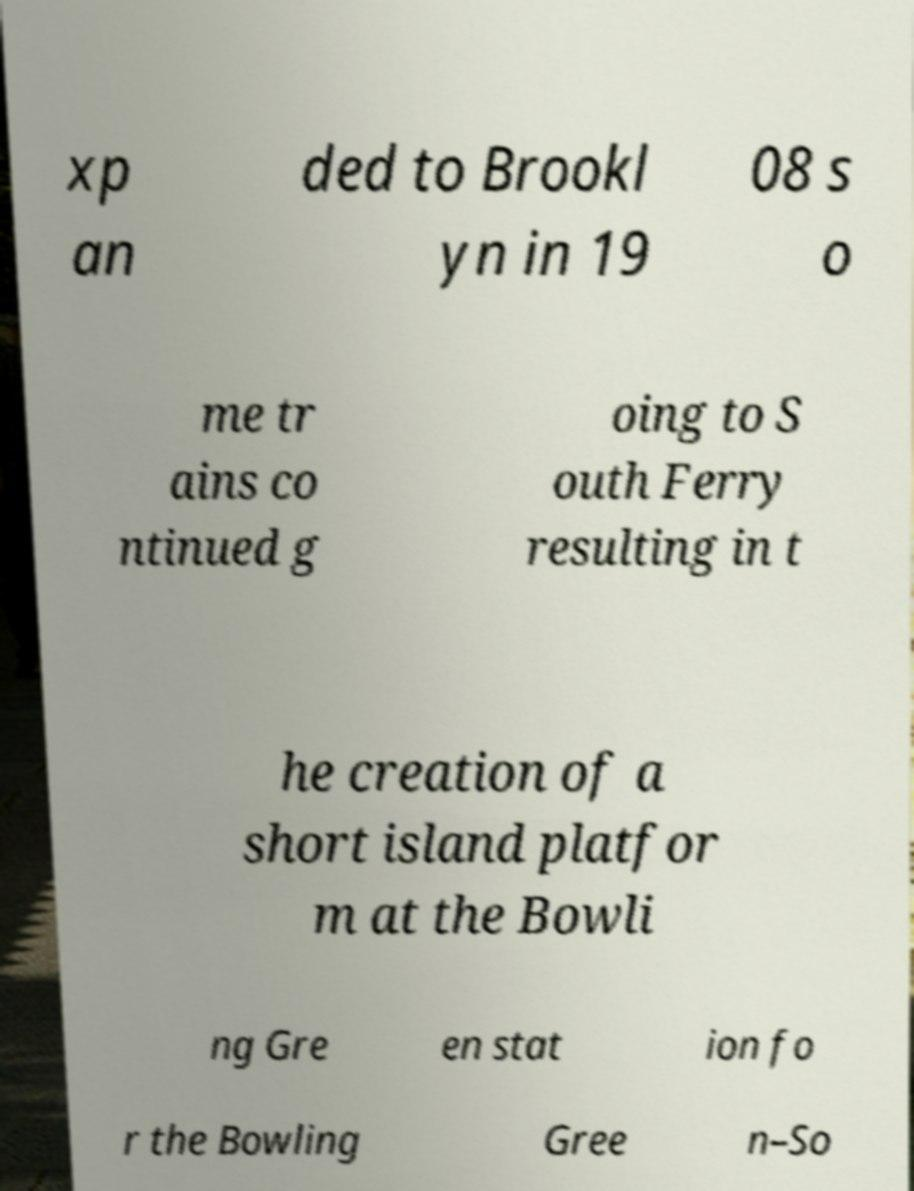What messages or text are displayed in this image? I need them in a readable, typed format. xp an ded to Brookl yn in 19 08 s o me tr ains co ntinued g oing to S outh Ferry resulting in t he creation of a short island platfor m at the Bowli ng Gre en stat ion fo r the Bowling Gree n–So 